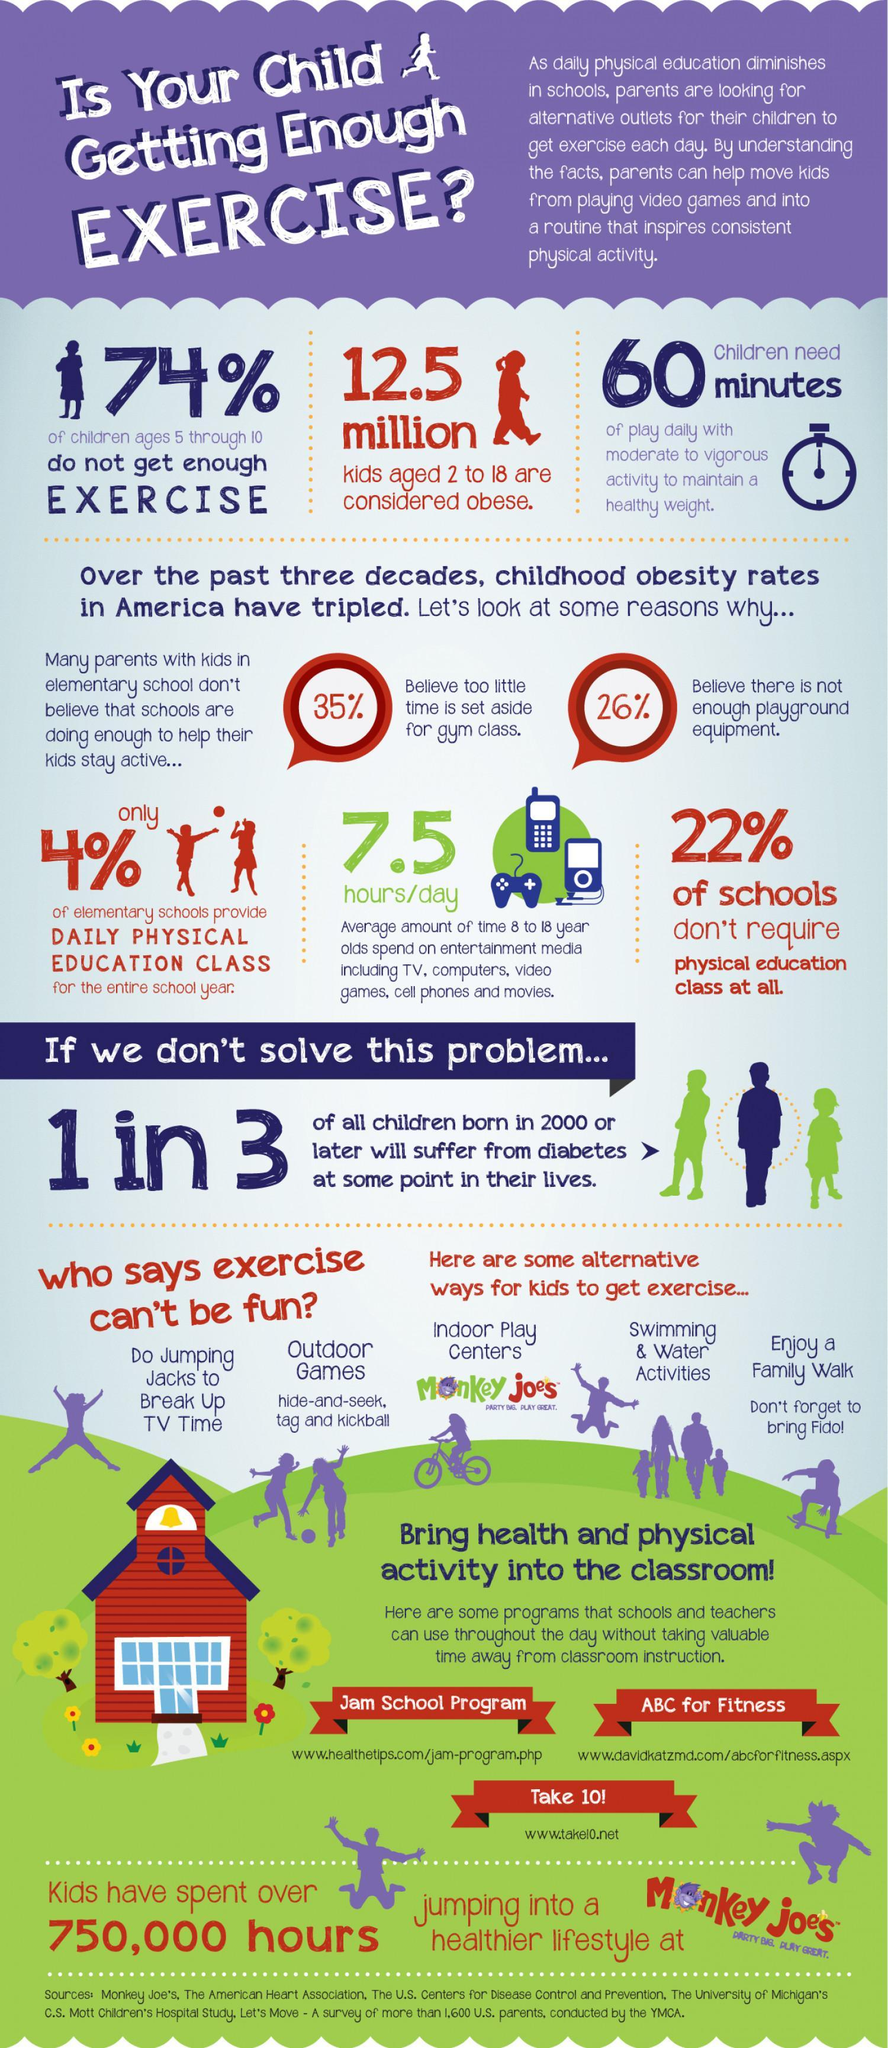What percentage of children aged 5-10 years in the U.S. do not get enough exercise as per the survey?
Answer the question with a short phrase. 74% What percent of the U.S. schools do not require physical education class according to the survey? 22% What percentage of the elementary schools in the U.S. provide daily physical education class for the entire school year as per the survey? only 4% How many children aged 2-18 years in the U.S. are considered obese as per the survey? 12.5 million 